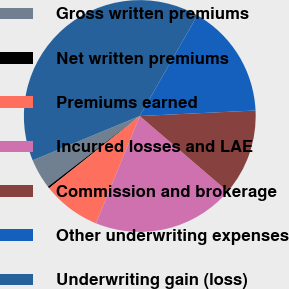Convert chart to OTSL. <chart><loc_0><loc_0><loc_500><loc_500><pie_chart><fcel>Gross written premiums<fcel>Net written premiums<fcel>Premiums earned<fcel>Incurred losses and LAE<fcel>Commission and brokerage<fcel>Other underwriting expenses<fcel>Underwriting gain (loss)<nl><fcel>4.19%<fcel>0.27%<fcel>8.12%<fcel>19.89%<fcel>12.04%<fcel>15.97%<fcel>39.52%<nl></chart> 